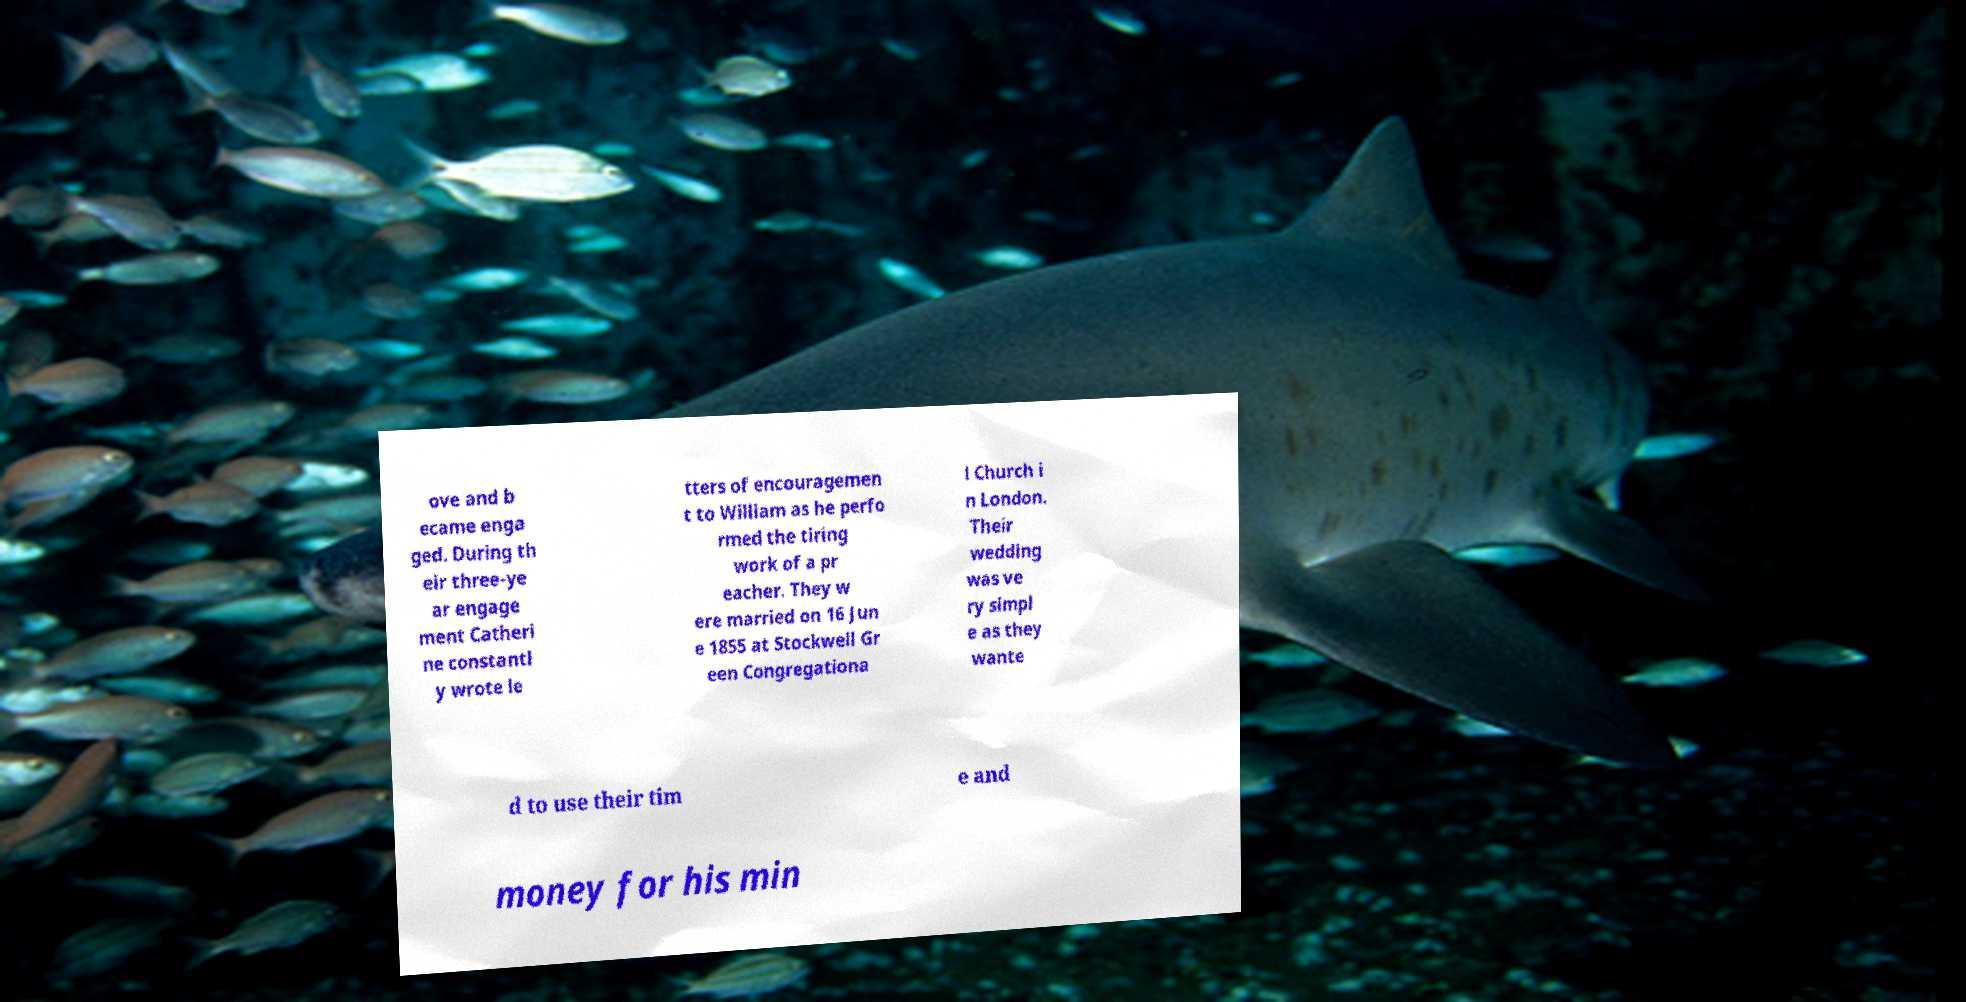There's text embedded in this image that I need extracted. Can you transcribe it verbatim? ove and b ecame enga ged. During th eir three-ye ar engage ment Catheri ne constantl y wrote le tters of encouragemen t to William as he perfo rmed the tiring work of a pr eacher. They w ere married on 16 Jun e 1855 at Stockwell Gr een Congregationa l Church i n London. Their wedding was ve ry simpl e as they wante d to use their tim e and money for his min 